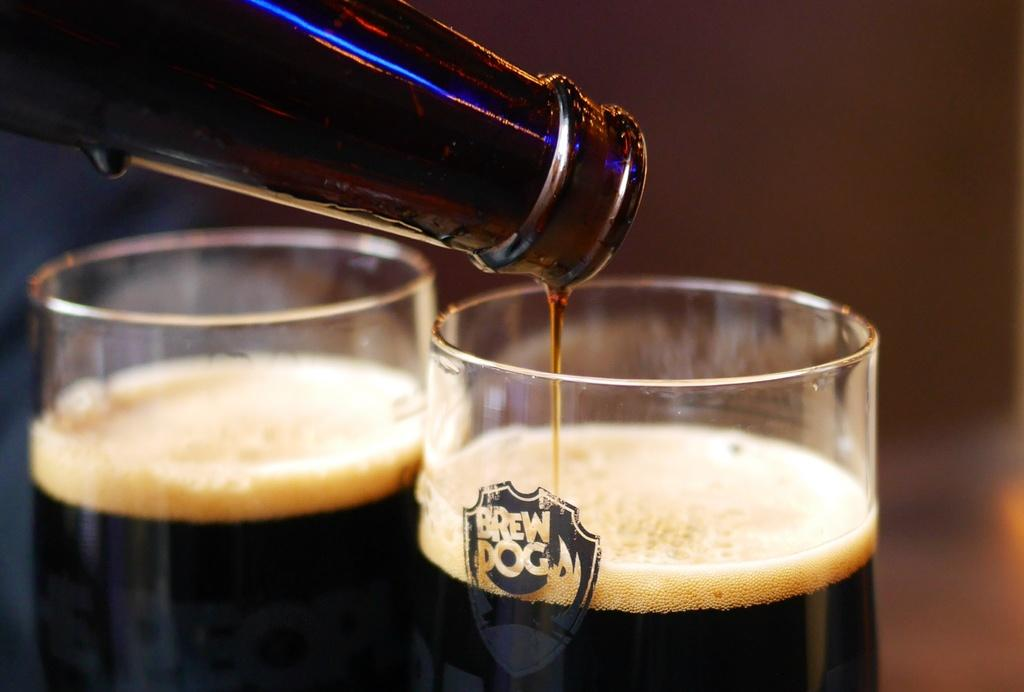<image>
Provide a brief description of the given image. a bottle is pouring a liquid into a glass with the words Brew Dog. 